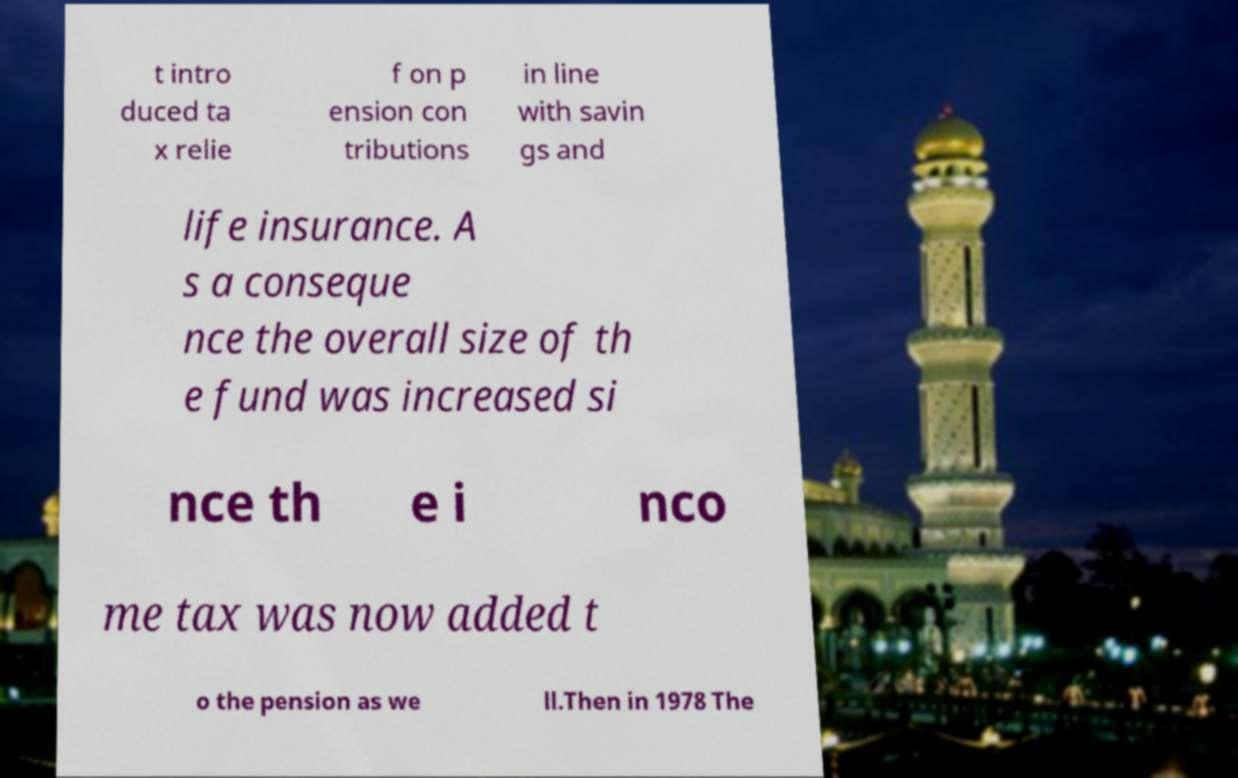Please identify and transcribe the text found in this image. t intro duced ta x relie f on p ension con tributions in line with savin gs and life insurance. A s a conseque nce the overall size of th e fund was increased si nce th e i nco me tax was now added t o the pension as we ll.Then in 1978 The 